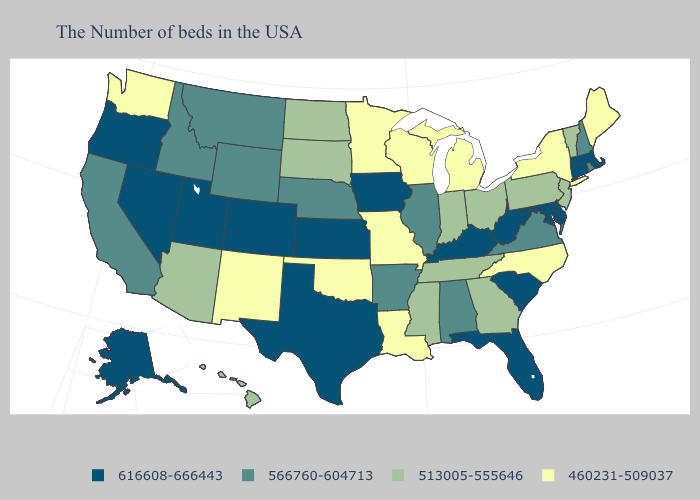What is the value of Massachusetts?
Keep it brief. 616608-666443. What is the highest value in states that border South Dakota?
Give a very brief answer. 616608-666443. Which states have the lowest value in the USA?
Concise answer only. Maine, New York, North Carolina, Michigan, Wisconsin, Louisiana, Missouri, Minnesota, Oklahoma, New Mexico, Washington. What is the highest value in the USA?
Quick response, please. 616608-666443. Name the states that have a value in the range 460231-509037?
Short answer required. Maine, New York, North Carolina, Michigan, Wisconsin, Louisiana, Missouri, Minnesota, Oklahoma, New Mexico, Washington. Among the states that border North Dakota , which have the highest value?
Write a very short answer. Montana. What is the value of California?
Give a very brief answer. 566760-604713. Is the legend a continuous bar?
Keep it brief. No. Name the states that have a value in the range 513005-555646?
Write a very short answer. Vermont, New Jersey, Pennsylvania, Ohio, Georgia, Indiana, Tennessee, Mississippi, South Dakota, North Dakota, Arizona, Hawaii. What is the highest value in states that border Alabama?
Write a very short answer. 616608-666443. Which states have the highest value in the USA?
Write a very short answer. Massachusetts, Connecticut, Delaware, Maryland, South Carolina, West Virginia, Florida, Kentucky, Iowa, Kansas, Texas, Colorado, Utah, Nevada, Oregon, Alaska. Name the states that have a value in the range 513005-555646?
Give a very brief answer. Vermont, New Jersey, Pennsylvania, Ohio, Georgia, Indiana, Tennessee, Mississippi, South Dakota, North Dakota, Arizona, Hawaii. Among the states that border Texas , does New Mexico have the lowest value?
Write a very short answer. Yes. Which states have the lowest value in the USA?
Quick response, please. Maine, New York, North Carolina, Michigan, Wisconsin, Louisiana, Missouri, Minnesota, Oklahoma, New Mexico, Washington. Name the states that have a value in the range 616608-666443?
Quick response, please. Massachusetts, Connecticut, Delaware, Maryland, South Carolina, West Virginia, Florida, Kentucky, Iowa, Kansas, Texas, Colorado, Utah, Nevada, Oregon, Alaska. 